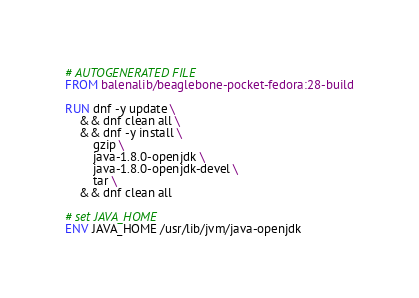<code> <loc_0><loc_0><loc_500><loc_500><_Dockerfile_># AUTOGENERATED FILE
FROM balenalib/beaglebone-pocket-fedora:28-build

RUN dnf -y update \
	&& dnf clean all \
	&& dnf -y install \
		gzip \
		java-1.8.0-openjdk \
		java-1.8.0-openjdk-devel \
		tar \
	&& dnf clean all

# set JAVA_HOME
ENV JAVA_HOME /usr/lib/jvm/java-openjdk
</code> 